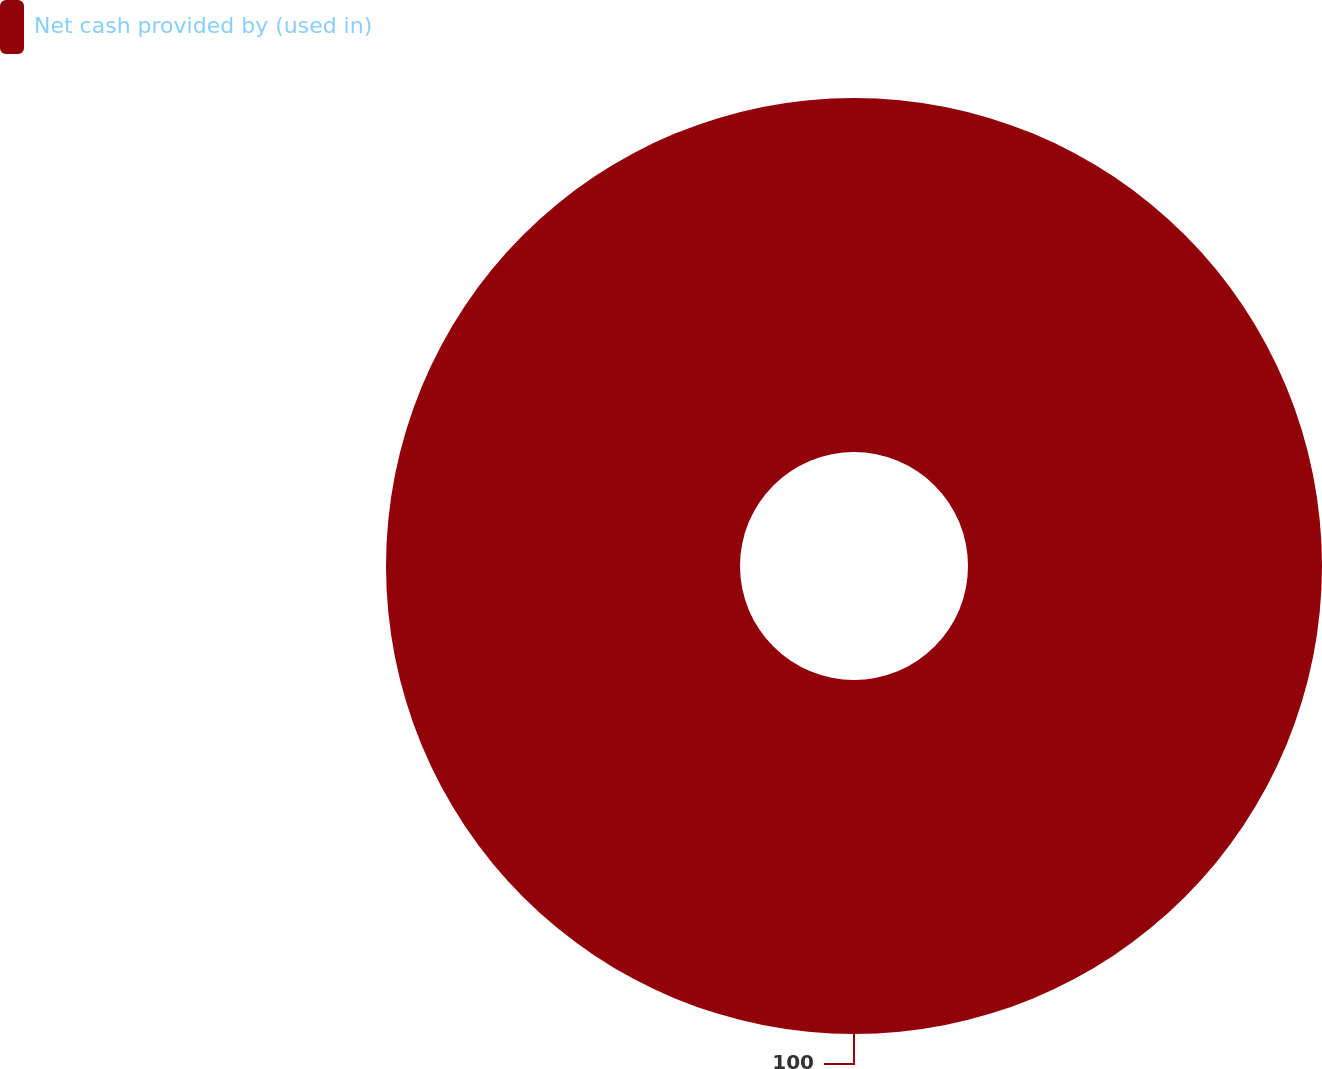Convert chart. <chart><loc_0><loc_0><loc_500><loc_500><pie_chart><fcel>Net cash provided by (used in)<nl><fcel>100.0%<nl></chart> 